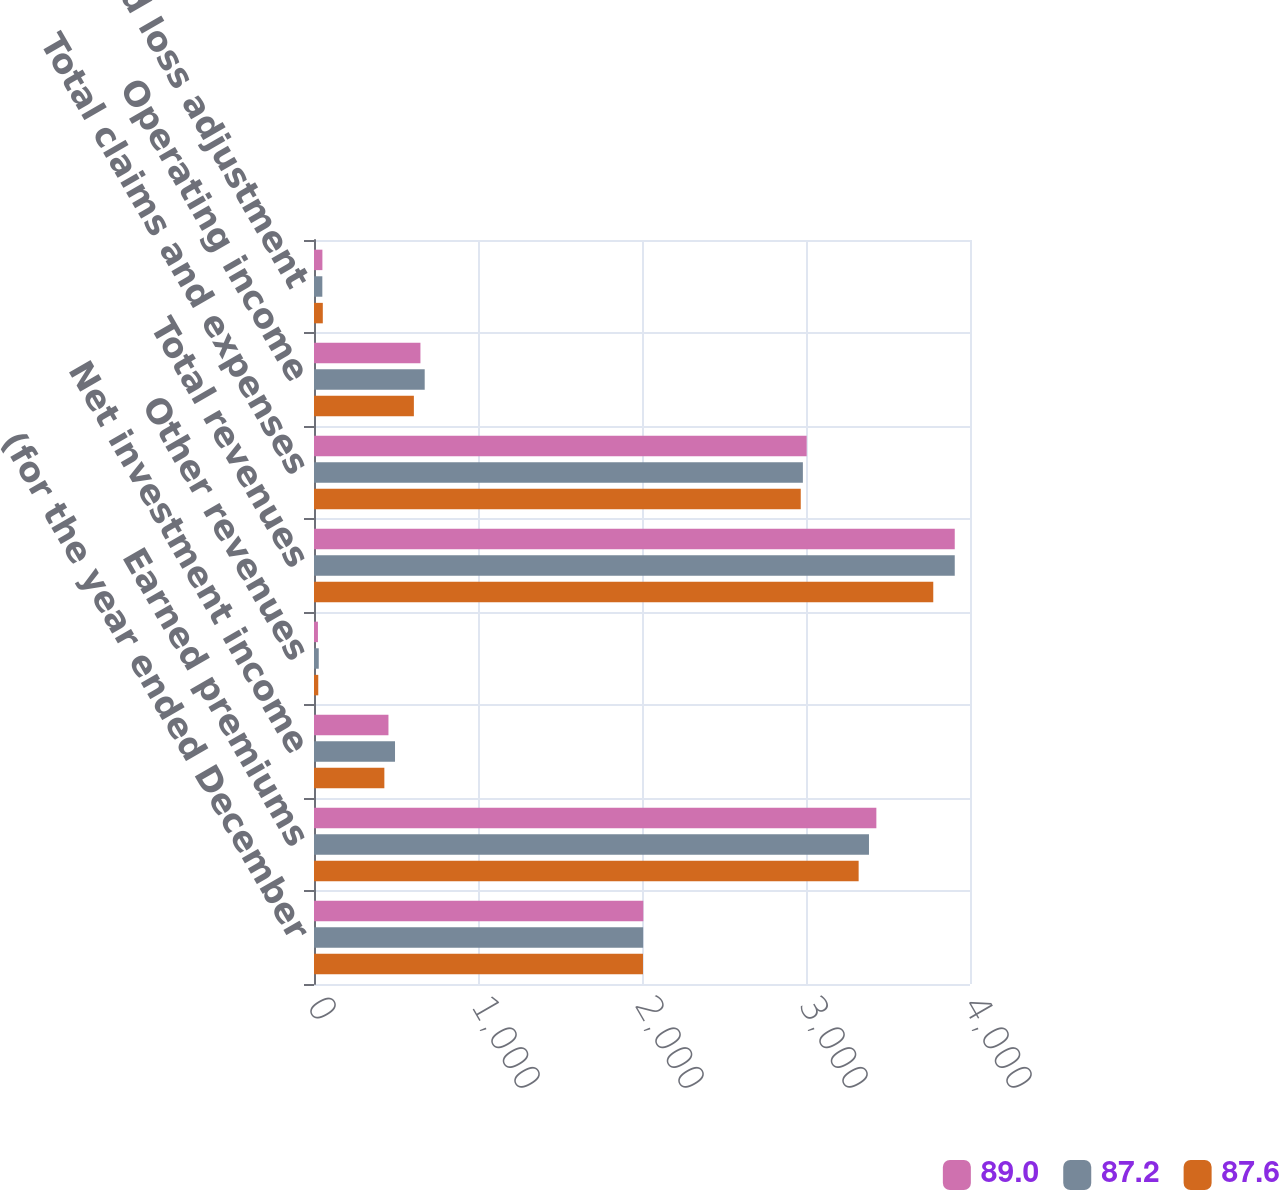Convert chart. <chart><loc_0><loc_0><loc_500><loc_500><stacked_bar_chart><ecel><fcel>(for the year ended December<fcel>Earned premiums<fcel>Net investment income<fcel>Other revenues<fcel>Total revenues<fcel>Total claims and expenses<fcel>Operating income<fcel>Loss and loss adjustment<nl><fcel>89<fcel>2008<fcel>3429<fcel>454<fcel>24<fcel>3907<fcel>3004<fcel>649<fcel>51.2<nl><fcel>87.2<fcel>2007<fcel>3384<fcel>494<fcel>29<fcel>3907<fcel>2981<fcel>675<fcel>50.8<nl><fcel>87.6<fcel>2006<fcel>3321<fcel>429<fcel>26<fcel>3776<fcel>2968<fcel>609<fcel>53.7<nl></chart> 